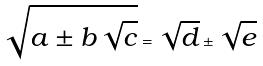<formula> <loc_0><loc_0><loc_500><loc_500>\sqrt { a \pm b \sqrt { c } } = \sqrt { d } \pm \sqrt { e }</formula> 